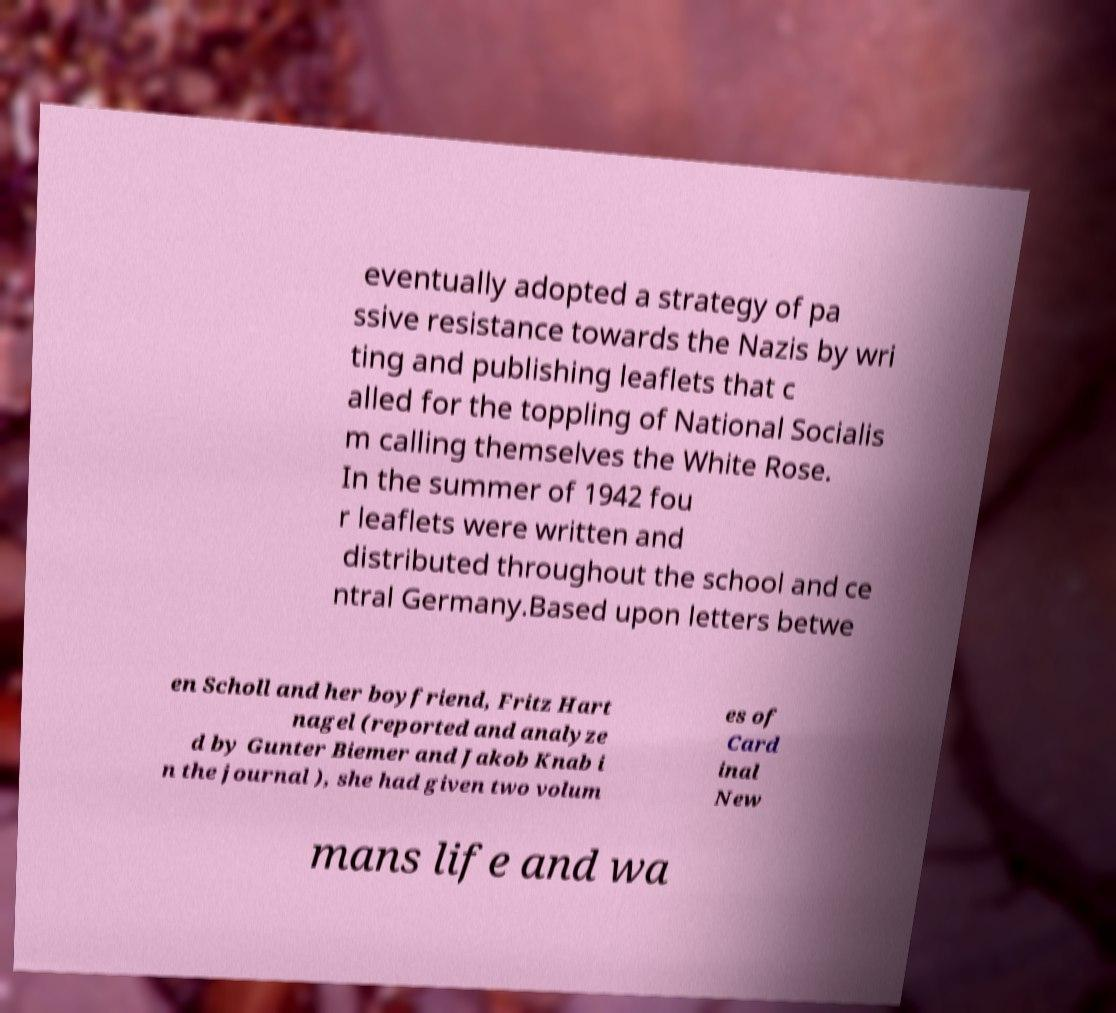Please identify and transcribe the text found in this image. eventually adopted a strategy of pa ssive resistance towards the Nazis by wri ting and publishing leaflets that c alled for the toppling of National Socialis m calling themselves the White Rose. In the summer of 1942 fou r leaflets were written and distributed throughout the school and ce ntral Germany.Based upon letters betwe en Scholl and her boyfriend, Fritz Hart nagel (reported and analyze d by Gunter Biemer and Jakob Knab i n the journal ), she had given two volum es of Card inal New mans life and wa 